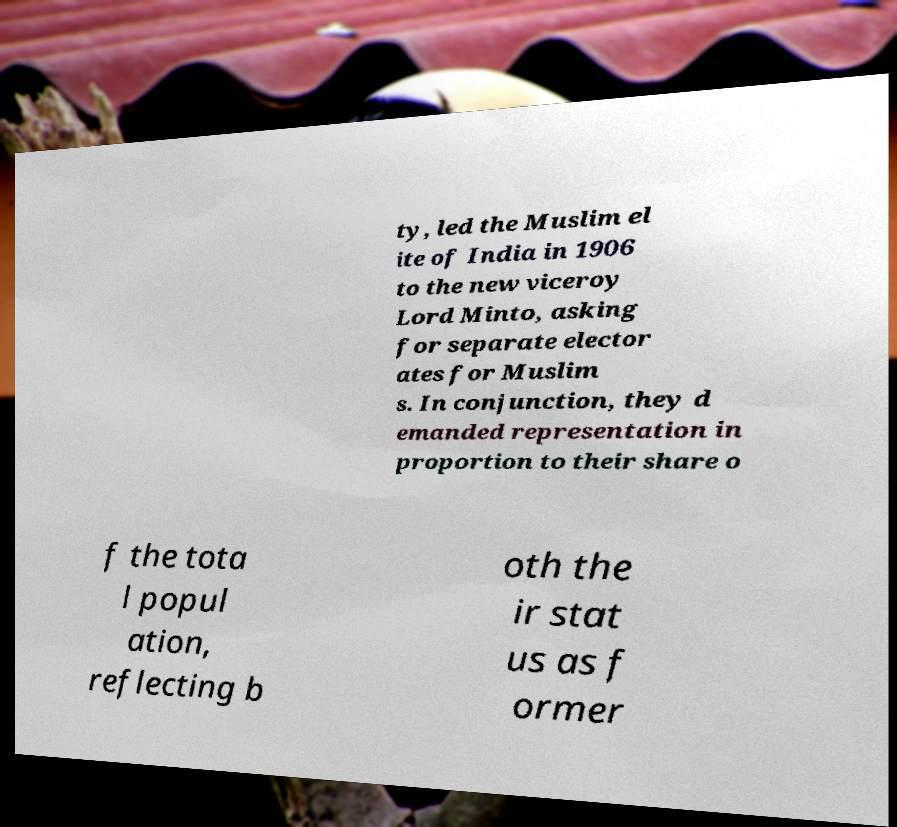Can you read and provide the text displayed in the image?This photo seems to have some interesting text. Can you extract and type it out for me? ty, led the Muslim el ite of India in 1906 to the new viceroy Lord Minto, asking for separate elector ates for Muslim s. In conjunction, they d emanded representation in proportion to their share o f the tota l popul ation, reflecting b oth the ir stat us as f ormer 